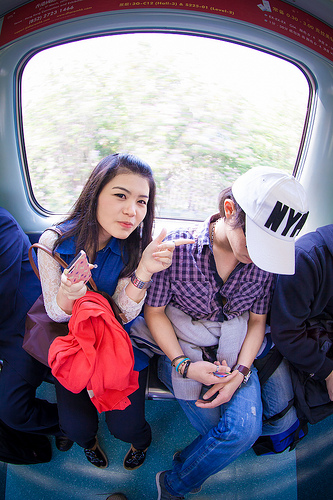<image>
Can you confirm if the hat is on the person? Yes. Looking at the image, I can see the hat is positioned on top of the person, with the person providing support. Is the woman to the left of the woman? Yes. From this viewpoint, the woman is positioned to the left side relative to the woman. 